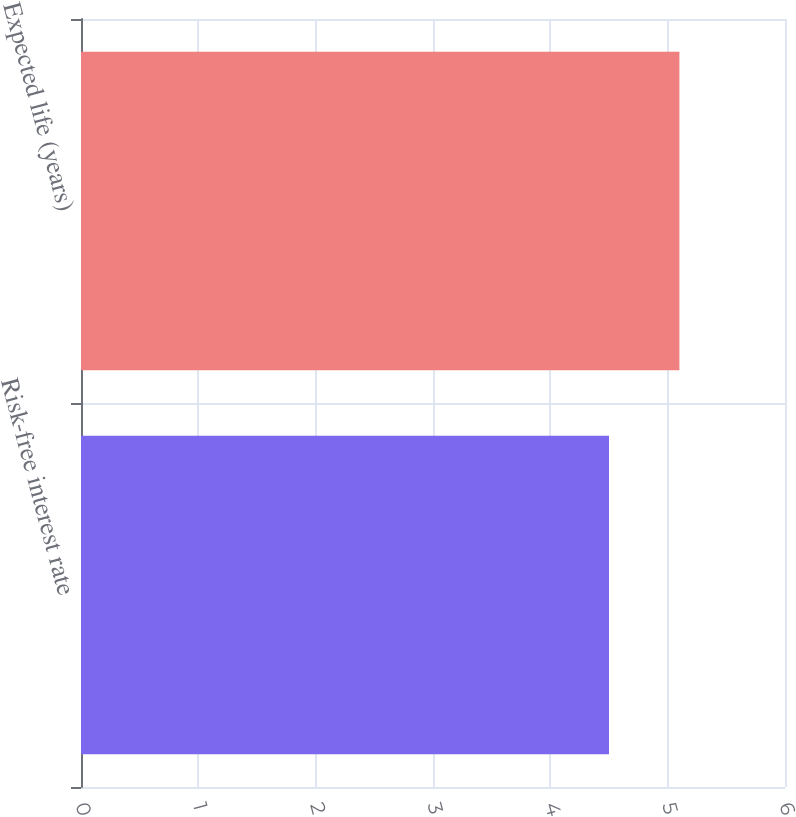Convert chart. <chart><loc_0><loc_0><loc_500><loc_500><bar_chart><fcel>Risk-free interest rate<fcel>Expected life (years)<nl><fcel>4.5<fcel>5.1<nl></chart> 